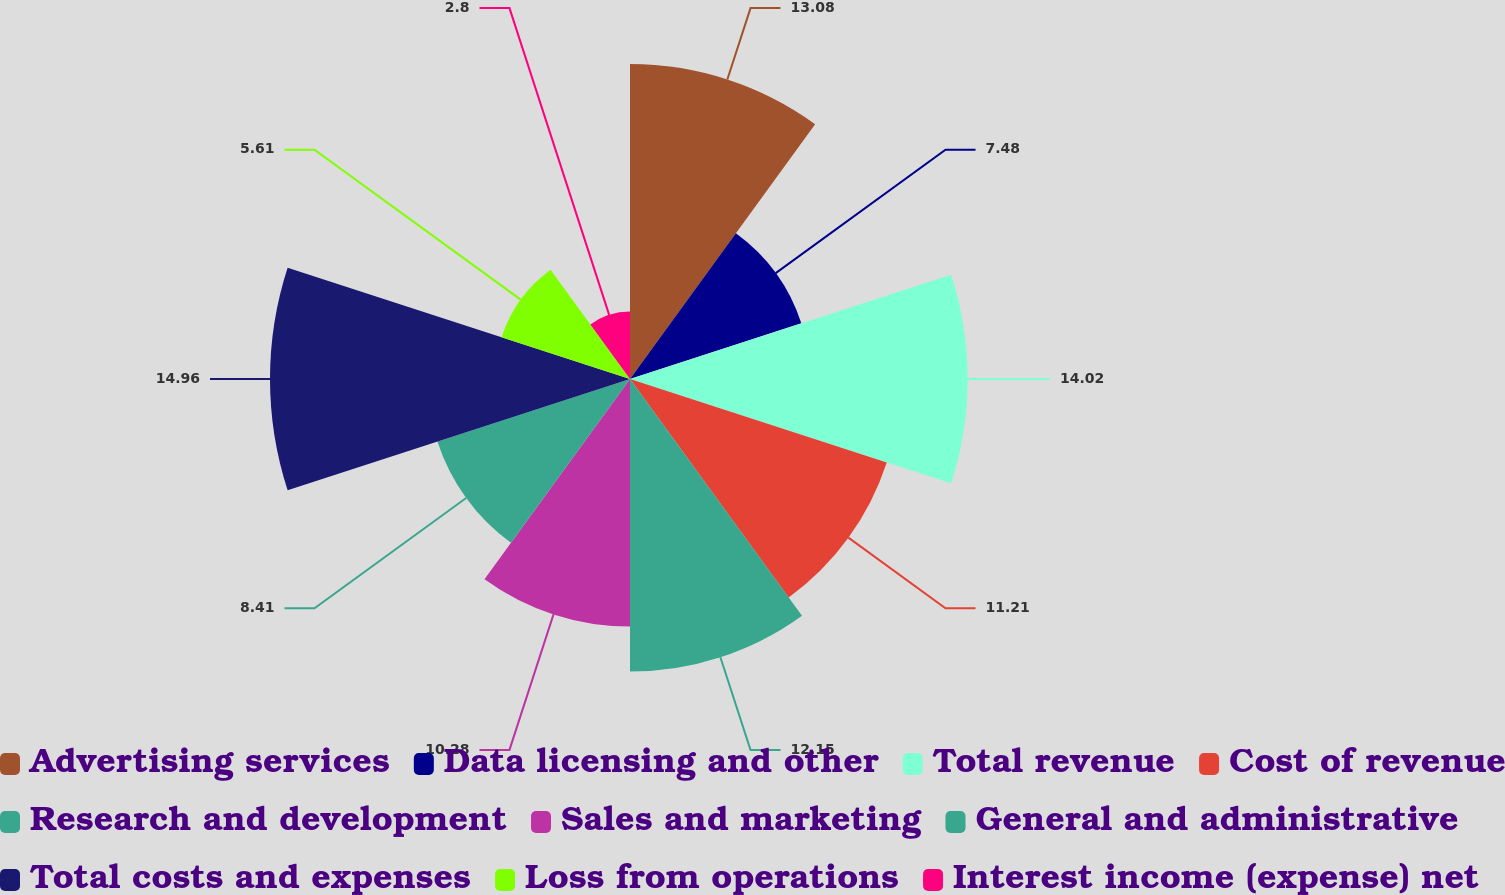Convert chart. <chart><loc_0><loc_0><loc_500><loc_500><pie_chart><fcel>Advertising services<fcel>Data licensing and other<fcel>Total revenue<fcel>Cost of revenue<fcel>Research and development<fcel>Sales and marketing<fcel>General and administrative<fcel>Total costs and expenses<fcel>Loss from operations<fcel>Interest income (expense) net<nl><fcel>13.08%<fcel>7.48%<fcel>14.02%<fcel>11.21%<fcel>12.15%<fcel>10.28%<fcel>8.41%<fcel>14.95%<fcel>5.61%<fcel>2.8%<nl></chart> 